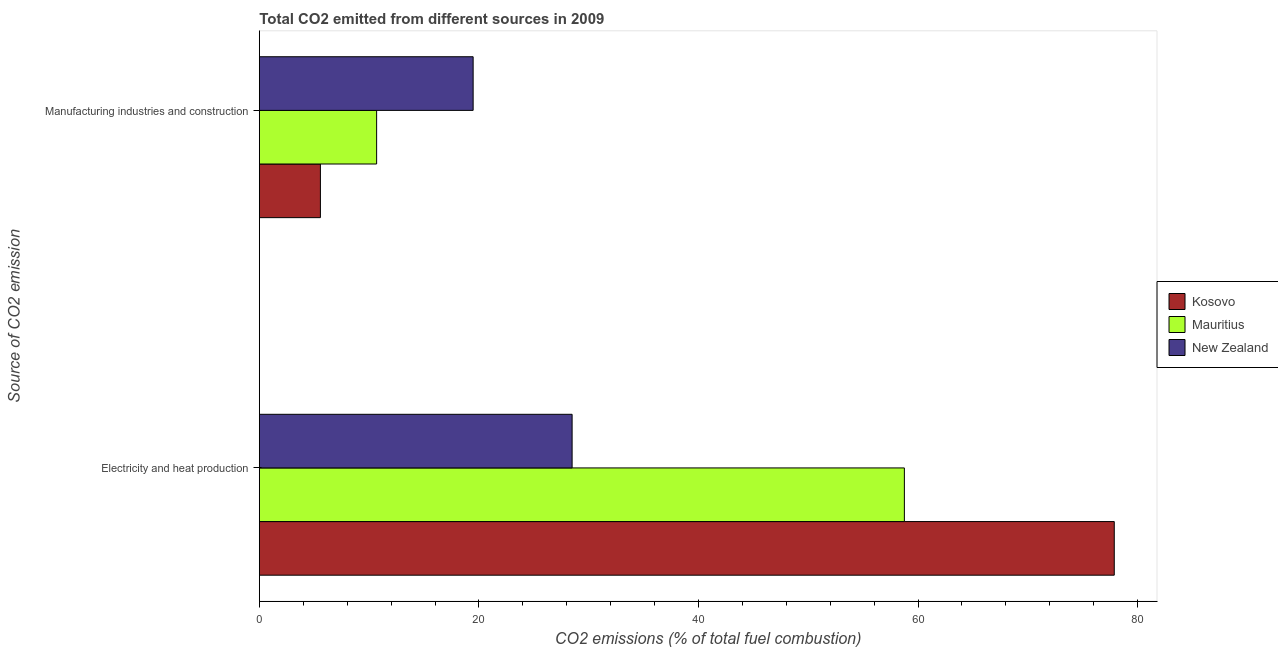How many different coloured bars are there?
Offer a terse response. 3. How many groups of bars are there?
Your answer should be very brief. 2. Are the number of bars on each tick of the Y-axis equal?
Ensure brevity in your answer.  Yes. How many bars are there on the 2nd tick from the bottom?
Your answer should be compact. 3. What is the label of the 1st group of bars from the top?
Keep it short and to the point. Manufacturing industries and construction. What is the co2 emissions due to manufacturing industries in Mauritius?
Your answer should be compact. 10.68. Across all countries, what is the maximum co2 emissions due to manufacturing industries?
Give a very brief answer. 19.47. Across all countries, what is the minimum co2 emissions due to manufacturing industries?
Ensure brevity in your answer.  5.56. In which country was the co2 emissions due to electricity and heat production maximum?
Your answer should be compact. Kosovo. In which country was the co2 emissions due to electricity and heat production minimum?
Your response must be concise. New Zealand. What is the total co2 emissions due to electricity and heat production in the graph?
Your answer should be very brief. 165.11. What is the difference between the co2 emissions due to electricity and heat production in New Zealand and that in Mauritius?
Provide a succinct answer. -30.26. What is the difference between the co2 emissions due to electricity and heat production in Kosovo and the co2 emissions due to manufacturing industries in New Zealand?
Offer a terse response. 58.4. What is the average co2 emissions due to electricity and heat production per country?
Your answer should be very brief. 55.04. What is the difference between the co2 emissions due to electricity and heat production and co2 emissions due to manufacturing industries in Mauritius?
Your response must be concise. 48.07. What is the ratio of the co2 emissions due to manufacturing industries in Mauritius to that in New Zealand?
Your answer should be very brief. 0.55. In how many countries, is the co2 emissions due to electricity and heat production greater than the average co2 emissions due to electricity and heat production taken over all countries?
Make the answer very short. 2. What does the 3rd bar from the top in Manufacturing industries and construction represents?
Your answer should be very brief. Kosovo. What does the 2nd bar from the bottom in Manufacturing industries and construction represents?
Ensure brevity in your answer.  Mauritius. Are all the bars in the graph horizontal?
Provide a short and direct response. Yes. Does the graph contain any zero values?
Offer a very short reply. No. Does the graph contain grids?
Make the answer very short. No. How many legend labels are there?
Your response must be concise. 3. What is the title of the graph?
Keep it short and to the point. Total CO2 emitted from different sources in 2009. What is the label or title of the X-axis?
Ensure brevity in your answer.  CO2 emissions (% of total fuel combustion). What is the label or title of the Y-axis?
Offer a very short reply. Source of CO2 emission. What is the CO2 emissions (% of total fuel combustion) of Kosovo in Electricity and heat production?
Provide a succinct answer. 77.87. What is the CO2 emissions (% of total fuel combustion) in Mauritius in Electricity and heat production?
Offer a very short reply. 58.75. What is the CO2 emissions (% of total fuel combustion) of New Zealand in Electricity and heat production?
Your answer should be very brief. 28.49. What is the CO2 emissions (% of total fuel combustion) in Kosovo in Manufacturing industries and construction?
Ensure brevity in your answer.  5.56. What is the CO2 emissions (% of total fuel combustion) of Mauritius in Manufacturing industries and construction?
Your answer should be compact. 10.68. What is the CO2 emissions (% of total fuel combustion) of New Zealand in Manufacturing industries and construction?
Provide a succinct answer. 19.47. Across all Source of CO2 emission, what is the maximum CO2 emissions (% of total fuel combustion) in Kosovo?
Your answer should be very brief. 77.87. Across all Source of CO2 emission, what is the maximum CO2 emissions (% of total fuel combustion) of Mauritius?
Your response must be concise. 58.75. Across all Source of CO2 emission, what is the maximum CO2 emissions (% of total fuel combustion) of New Zealand?
Ensure brevity in your answer.  28.49. Across all Source of CO2 emission, what is the minimum CO2 emissions (% of total fuel combustion) of Kosovo?
Provide a succinct answer. 5.56. Across all Source of CO2 emission, what is the minimum CO2 emissions (% of total fuel combustion) in Mauritius?
Offer a terse response. 10.68. Across all Source of CO2 emission, what is the minimum CO2 emissions (% of total fuel combustion) in New Zealand?
Provide a succinct answer. 19.47. What is the total CO2 emissions (% of total fuel combustion) in Kosovo in the graph?
Give a very brief answer. 83.43. What is the total CO2 emissions (% of total fuel combustion) in Mauritius in the graph?
Ensure brevity in your answer.  69.44. What is the total CO2 emissions (% of total fuel combustion) of New Zealand in the graph?
Your response must be concise. 47.96. What is the difference between the CO2 emissions (% of total fuel combustion) in Kosovo in Electricity and heat production and that in Manufacturing industries and construction?
Your answer should be compact. 72.31. What is the difference between the CO2 emissions (% of total fuel combustion) in Mauritius in Electricity and heat production and that in Manufacturing industries and construction?
Your answer should be compact. 48.07. What is the difference between the CO2 emissions (% of total fuel combustion) in New Zealand in Electricity and heat production and that in Manufacturing industries and construction?
Offer a very short reply. 9.02. What is the difference between the CO2 emissions (% of total fuel combustion) of Kosovo in Electricity and heat production and the CO2 emissions (% of total fuel combustion) of Mauritius in Manufacturing industries and construction?
Make the answer very short. 67.19. What is the difference between the CO2 emissions (% of total fuel combustion) in Kosovo in Electricity and heat production and the CO2 emissions (% of total fuel combustion) in New Zealand in Manufacturing industries and construction?
Provide a succinct answer. 58.4. What is the difference between the CO2 emissions (% of total fuel combustion) of Mauritius in Electricity and heat production and the CO2 emissions (% of total fuel combustion) of New Zealand in Manufacturing industries and construction?
Make the answer very short. 39.28. What is the average CO2 emissions (% of total fuel combustion) of Kosovo per Source of CO2 emission?
Give a very brief answer. 41.72. What is the average CO2 emissions (% of total fuel combustion) in Mauritius per Source of CO2 emission?
Provide a succinct answer. 34.72. What is the average CO2 emissions (% of total fuel combustion) in New Zealand per Source of CO2 emission?
Give a very brief answer. 23.98. What is the difference between the CO2 emissions (% of total fuel combustion) in Kosovo and CO2 emissions (% of total fuel combustion) in Mauritius in Electricity and heat production?
Offer a terse response. 19.12. What is the difference between the CO2 emissions (% of total fuel combustion) of Kosovo and CO2 emissions (% of total fuel combustion) of New Zealand in Electricity and heat production?
Ensure brevity in your answer.  49.38. What is the difference between the CO2 emissions (% of total fuel combustion) in Mauritius and CO2 emissions (% of total fuel combustion) in New Zealand in Electricity and heat production?
Make the answer very short. 30.26. What is the difference between the CO2 emissions (% of total fuel combustion) in Kosovo and CO2 emissions (% of total fuel combustion) in Mauritius in Manufacturing industries and construction?
Your response must be concise. -5.12. What is the difference between the CO2 emissions (% of total fuel combustion) of Kosovo and CO2 emissions (% of total fuel combustion) of New Zealand in Manufacturing industries and construction?
Offer a very short reply. -13.91. What is the difference between the CO2 emissions (% of total fuel combustion) in Mauritius and CO2 emissions (% of total fuel combustion) in New Zealand in Manufacturing industries and construction?
Provide a short and direct response. -8.79. What is the ratio of the CO2 emissions (% of total fuel combustion) of Mauritius in Electricity and heat production to that in Manufacturing industries and construction?
Offer a very short reply. 5.5. What is the ratio of the CO2 emissions (% of total fuel combustion) of New Zealand in Electricity and heat production to that in Manufacturing industries and construction?
Your answer should be compact. 1.46. What is the difference between the highest and the second highest CO2 emissions (% of total fuel combustion) of Kosovo?
Offer a terse response. 72.31. What is the difference between the highest and the second highest CO2 emissions (% of total fuel combustion) of Mauritius?
Your answer should be very brief. 48.07. What is the difference between the highest and the second highest CO2 emissions (% of total fuel combustion) in New Zealand?
Your answer should be very brief. 9.02. What is the difference between the highest and the lowest CO2 emissions (% of total fuel combustion) in Kosovo?
Ensure brevity in your answer.  72.31. What is the difference between the highest and the lowest CO2 emissions (% of total fuel combustion) in Mauritius?
Your response must be concise. 48.07. What is the difference between the highest and the lowest CO2 emissions (% of total fuel combustion) of New Zealand?
Provide a succinct answer. 9.02. 